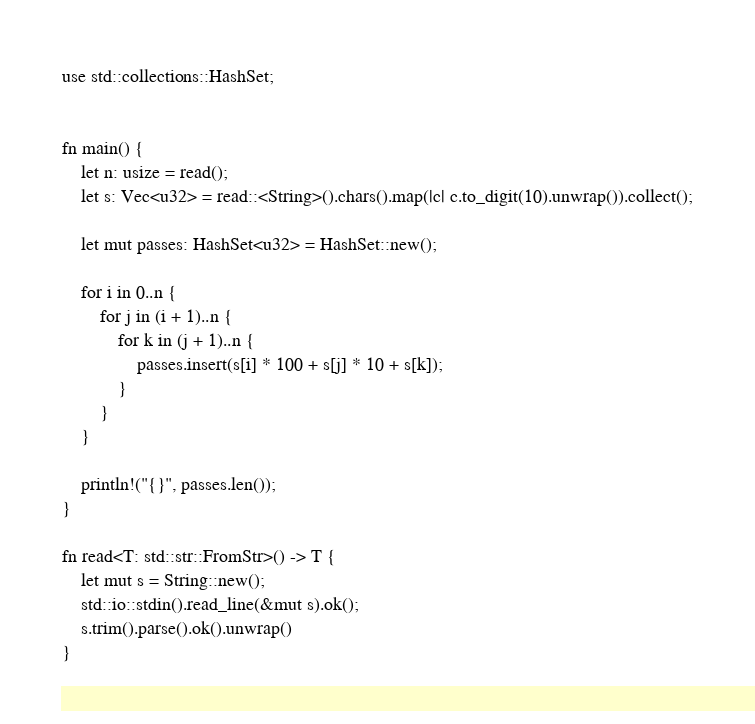Convert code to text. <code><loc_0><loc_0><loc_500><loc_500><_Rust_>use std::collections::HashSet;


fn main() {
    let n: usize = read();
    let s: Vec<u32> = read::<String>().chars().map(|c| c.to_digit(10).unwrap()).collect();

    let mut passes: HashSet<u32> = HashSet::new();

    for i in 0..n {
        for j in (i + 1)..n {
            for k in (j + 1)..n {
                passes.insert(s[i] * 100 + s[j] * 10 + s[k]);
            }
        }
    }

    println!("{}", passes.len());
}

fn read<T: std::str::FromStr>() -> T {
    let mut s = String::new();
    std::io::stdin().read_line(&mut s).ok();
    s.trim().parse().ok().unwrap()
}
</code> 